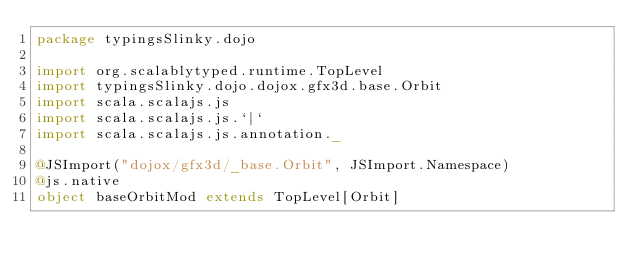Convert code to text. <code><loc_0><loc_0><loc_500><loc_500><_Scala_>package typingsSlinky.dojo

import org.scalablytyped.runtime.TopLevel
import typingsSlinky.dojo.dojox.gfx3d.base.Orbit
import scala.scalajs.js
import scala.scalajs.js.`|`
import scala.scalajs.js.annotation._

@JSImport("dojox/gfx3d/_base.Orbit", JSImport.Namespace)
@js.native
object baseOrbitMod extends TopLevel[Orbit]

</code> 